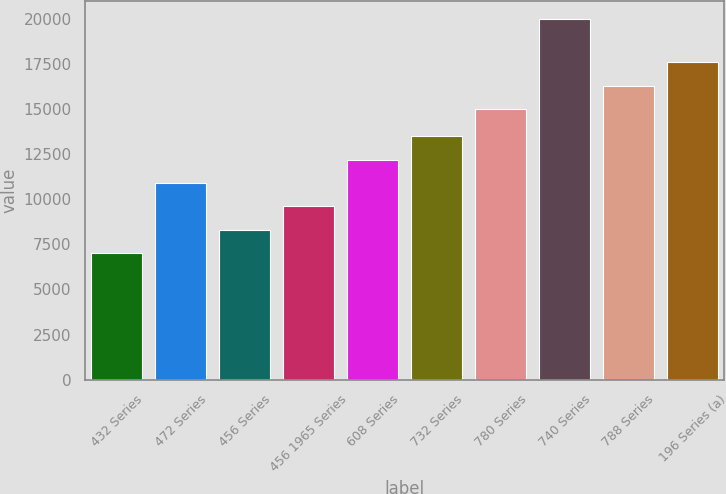Convert chart. <chart><loc_0><loc_0><loc_500><loc_500><bar_chart><fcel>432 Series<fcel>472 Series<fcel>456 Series<fcel>456 1965 Series<fcel>608 Series<fcel>732 Series<fcel>780 Series<fcel>740 Series<fcel>788 Series<fcel>196 Series (a)<nl><fcel>7000<fcel>10900<fcel>8300<fcel>9600<fcel>12200<fcel>13500<fcel>15000<fcel>20000<fcel>16300<fcel>17600<nl></chart> 